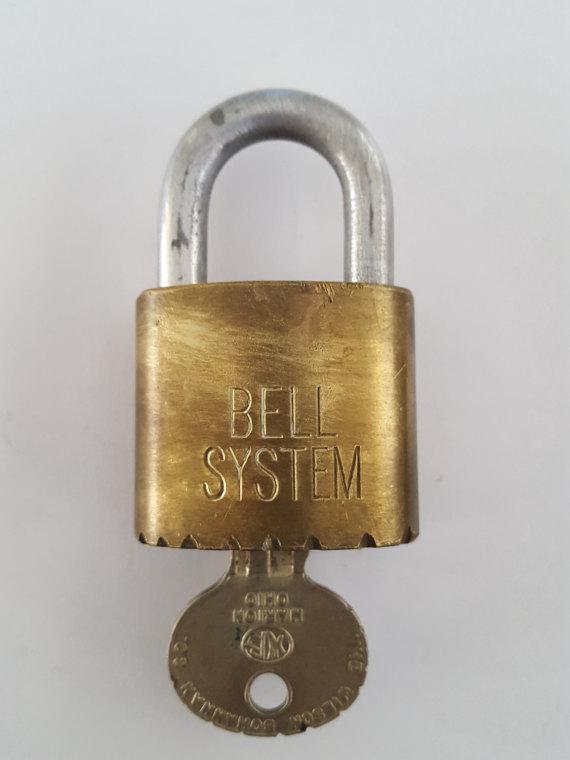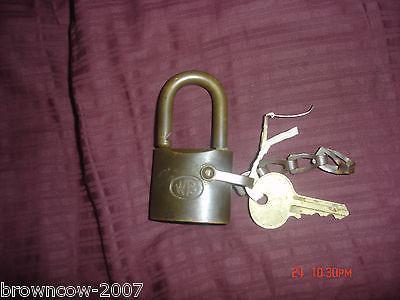The first image is the image on the left, the second image is the image on the right. Assess this claim about the two images: "A key is in a single lock in the image on the left.". Correct or not? Answer yes or no. Yes. 